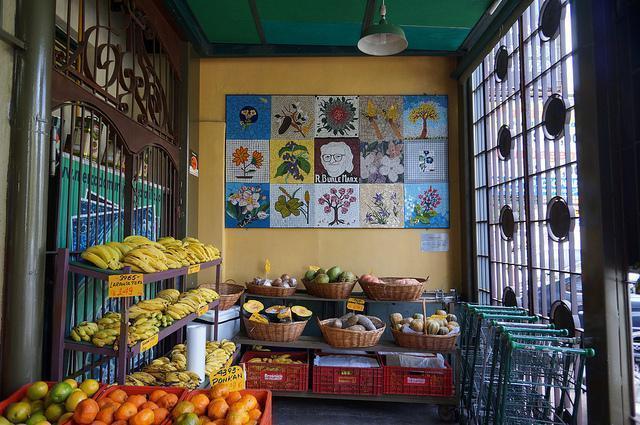Why are the fruits in the basket?
Select the correct answer and articulate reasoning with the following format: 'Answer: answer
Rationale: rationale.'
Options: To clean, to sell, to decorate, to eat. Answer: to sell.
Rationale: There a prices listed on the baskets and shopping carts next to them. 